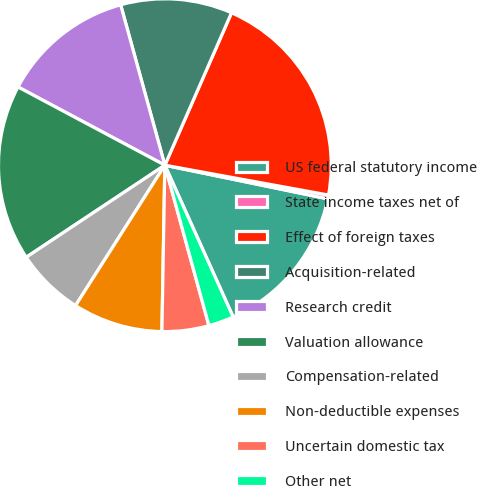Convert chart to OTSL. <chart><loc_0><loc_0><loc_500><loc_500><pie_chart><fcel>US federal statutory income<fcel>State income taxes net of<fcel>Effect of foreign taxes<fcel>Acquisition-related<fcel>Research credit<fcel>Valuation allowance<fcel>Compensation-related<fcel>Non-deductible expenses<fcel>Uncertain domestic tax<fcel>Other net<nl><fcel>15.03%<fcel>0.37%<fcel>21.31%<fcel>10.84%<fcel>12.93%<fcel>17.12%<fcel>6.65%<fcel>8.74%<fcel>4.55%<fcel>2.46%<nl></chart> 